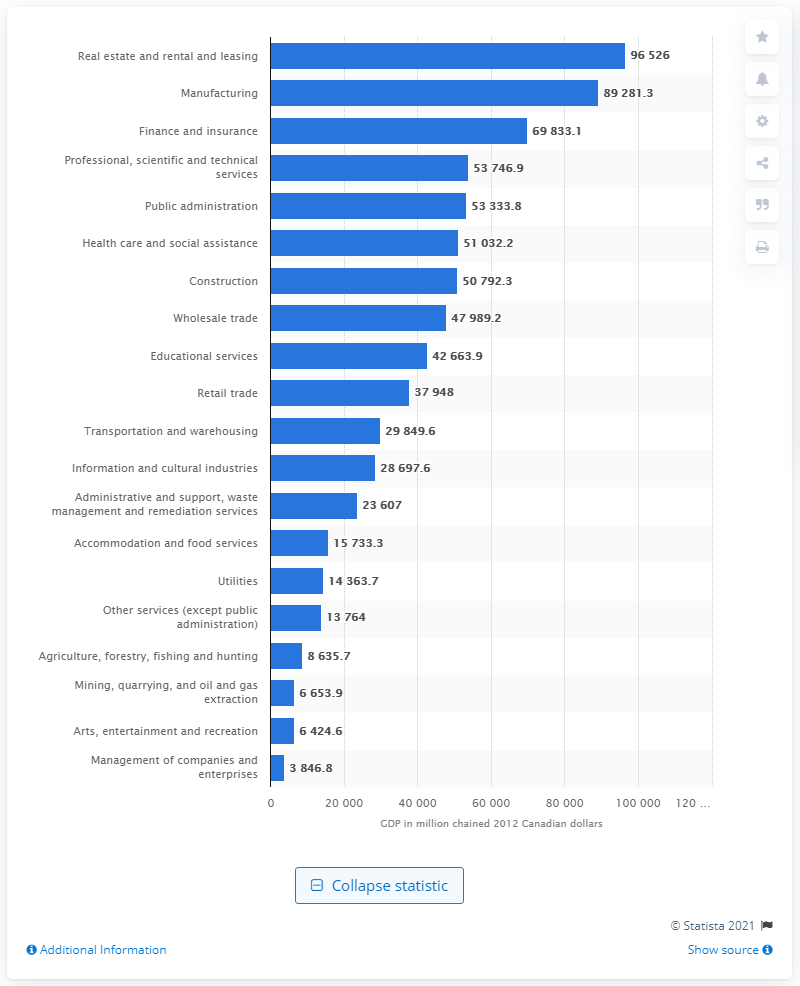Highlight a few significant elements in this photo. In 2012, the Gross Domestic Product (GDP) of the construction industry in Ontario was 51,032.2 Canadian dollars. 